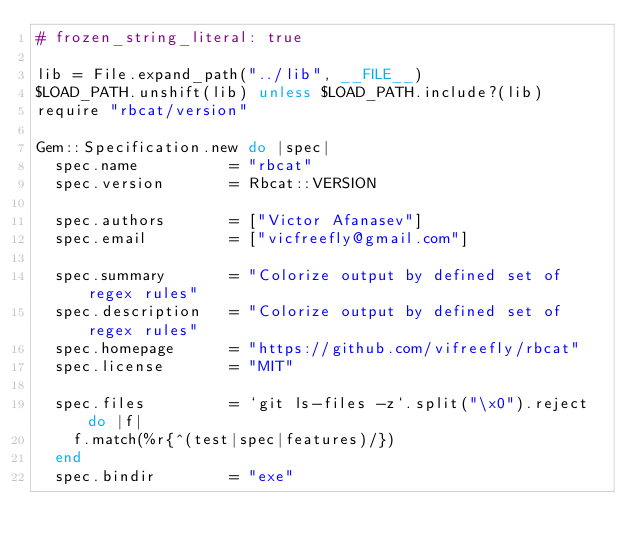Convert code to text. <code><loc_0><loc_0><loc_500><loc_500><_Ruby_># frozen_string_literal: true

lib = File.expand_path("../lib", __FILE__)
$LOAD_PATH.unshift(lib) unless $LOAD_PATH.include?(lib)
require "rbcat/version"

Gem::Specification.new do |spec|
  spec.name          = "rbcat"
  spec.version       = Rbcat::VERSION

  spec.authors       = ["Victor Afanasev"]
  spec.email         = ["vicfreefly@gmail.com"]

  spec.summary       = "Colorize output by defined set of regex rules"
  spec.description   = "Colorize output by defined set of regex rules"
  spec.homepage      = "https://github.com/vifreefly/rbcat"
  spec.license       = "MIT"

  spec.files         = `git ls-files -z`.split("\x0").reject do |f|
    f.match(%r{^(test|spec|features)/})
  end
  spec.bindir        = "exe"</code> 